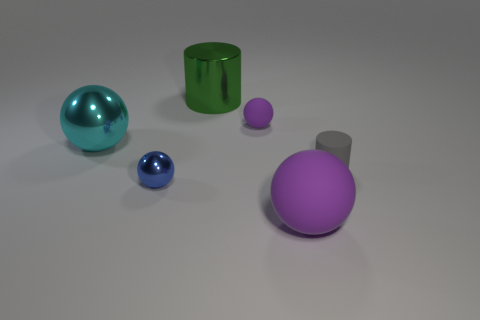Add 1 balls. How many objects exist? 7 Subtract all small purple matte balls. How many balls are left? 3 Subtract all brown cubes. How many purple spheres are left? 2 Subtract all purple spheres. How many spheres are left? 2 Subtract all spheres. How many objects are left? 2 Subtract all gray spheres. Subtract all blue cubes. How many spheres are left? 4 Subtract all matte cylinders. Subtract all blue shiny objects. How many objects are left? 4 Add 2 green metal things. How many green metal things are left? 3 Add 2 large green matte spheres. How many large green matte spheres exist? 2 Subtract 0 red cylinders. How many objects are left? 6 